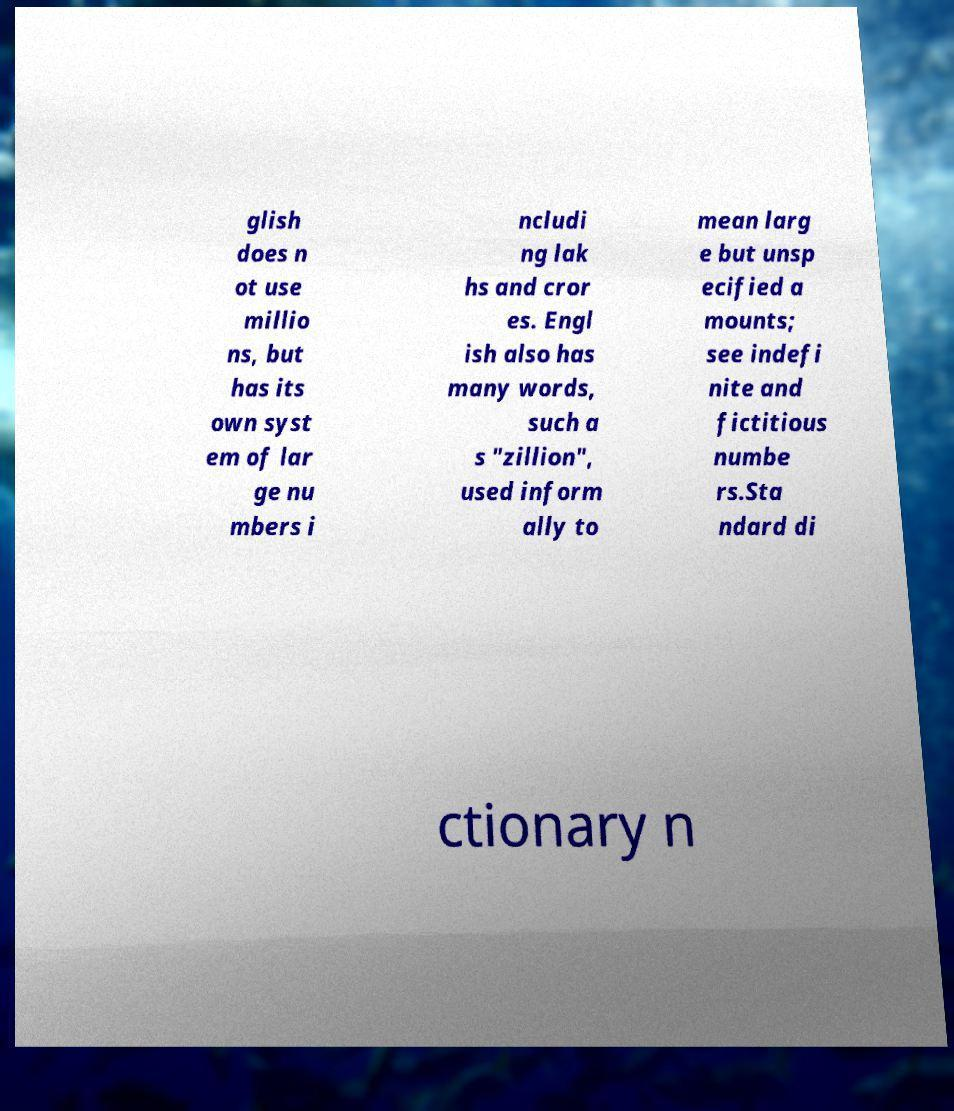I need the written content from this picture converted into text. Can you do that? glish does n ot use millio ns, but has its own syst em of lar ge nu mbers i ncludi ng lak hs and cror es. Engl ish also has many words, such a s "zillion", used inform ally to mean larg e but unsp ecified a mounts; see indefi nite and fictitious numbe rs.Sta ndard di ctionary n 